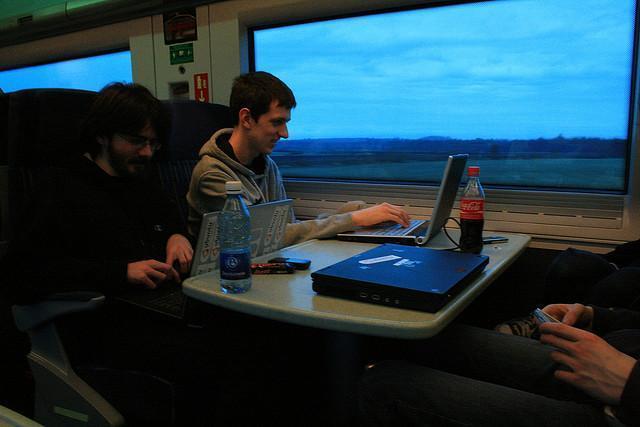How many laptops are there?
Give a very brief answer. 3. How many people can be seen?
Give a very brief answer. 4. How many laptops can be seen?
Give a very brief answer. 3. 